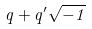Convert formula to latex. <formula><loc_0><loc_0><loc_500><loc_500>q + q ^ { \prime } { \sqrt { - 1 } }</formula> 